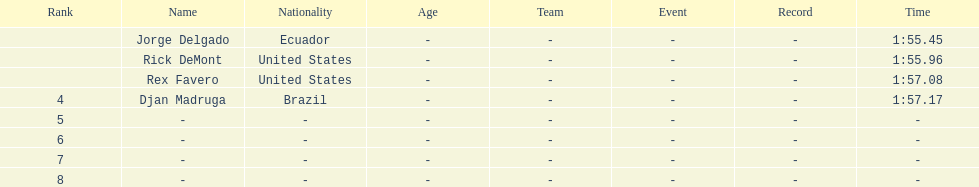What is the average time? 1:56.42. 